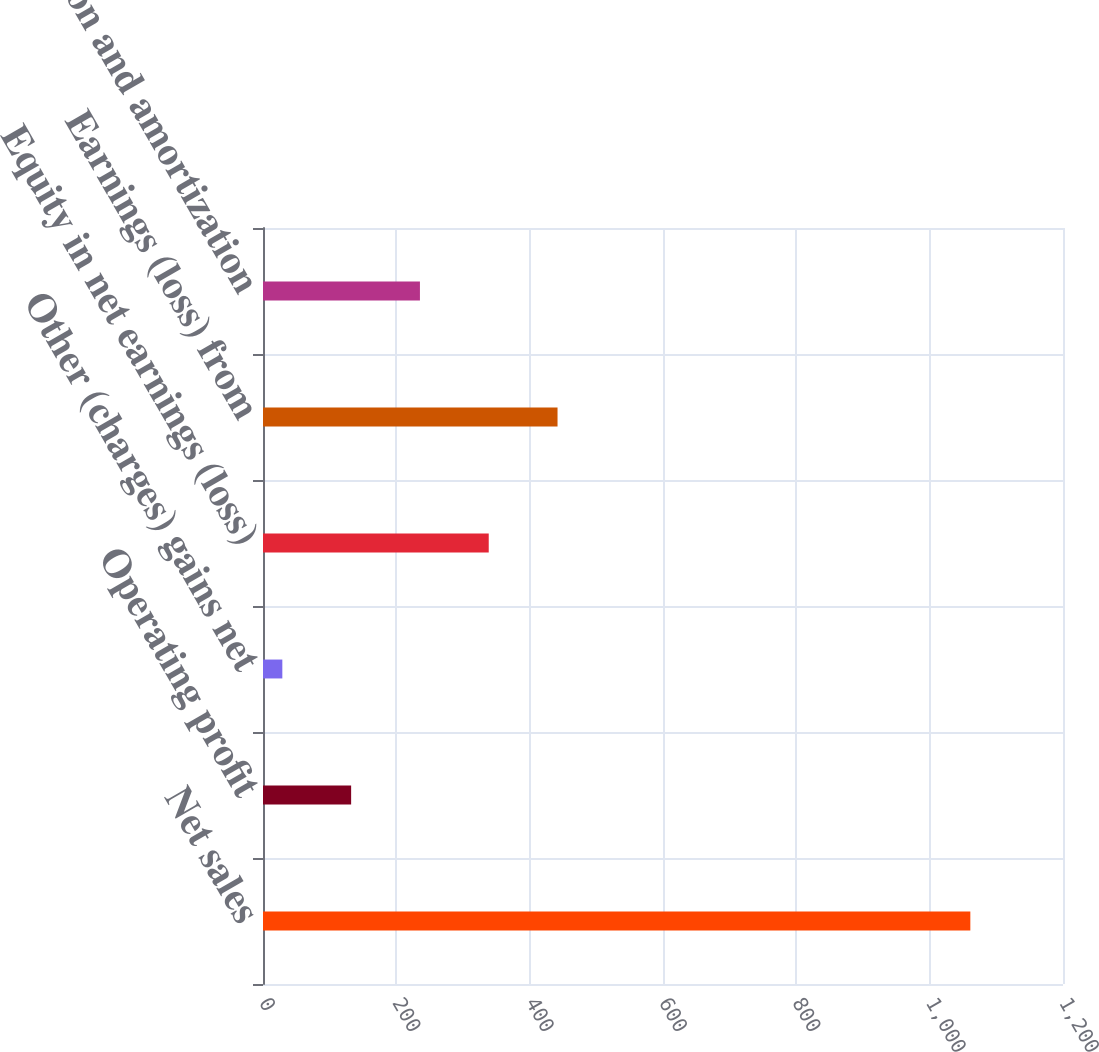Convert chart. <chart><loc_0><loc_0><loc_500><loc_500><bar_chart><fcel>Net sales<fcel>Operating profit<fcel>Other (charges) gains net<fcel>Equity in net earnings (loss)<fcel>Earnings (loss) from<fcel>Depreciation and amortization<nl><fcel>1061<fcel>132.2<fcel>29<fcel>338.6<fcel>441.8<fcel>235.4<nl></chart> 